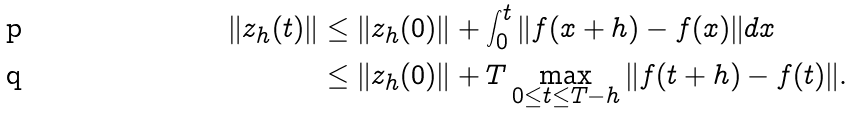Convert formula to latex. <formula><loc_0><loc_0><loc_500><loc_500>\| z _ { h } ( t ) \| & \leq \| z _ { h } ( 0 ) \| + \int _ { 0 } ^ { t } \| f ( x + h ) - f ( x ) \| d x \\ & \leq \| z _ { h } ( 0 ) \| + T \max _ { 0 \leq t \leq T - h } \| f ( t + h ) - f ( t ) \| .</formula> 